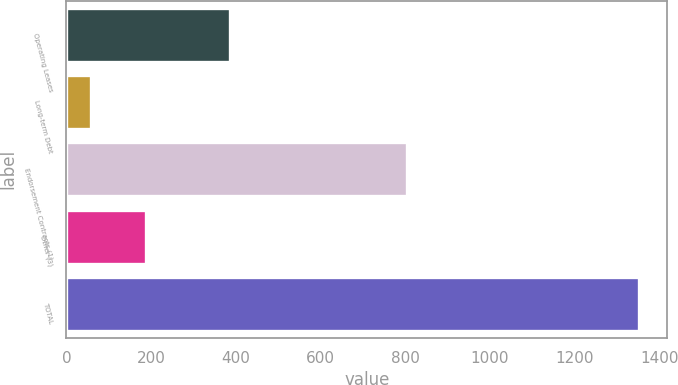<chart> <loc_0><loc_0><loc_500><loc_500><bar_chart><fcel>Operating Leases<fcel>Long-term Debt<fcel>Endorsement Contracts (1)<fcel>Other (3)<fcel>TOTAL<nl><fcel>387<fcel>59<fcel>804<fcel>188.2<fcel>1351<nl></chart> 